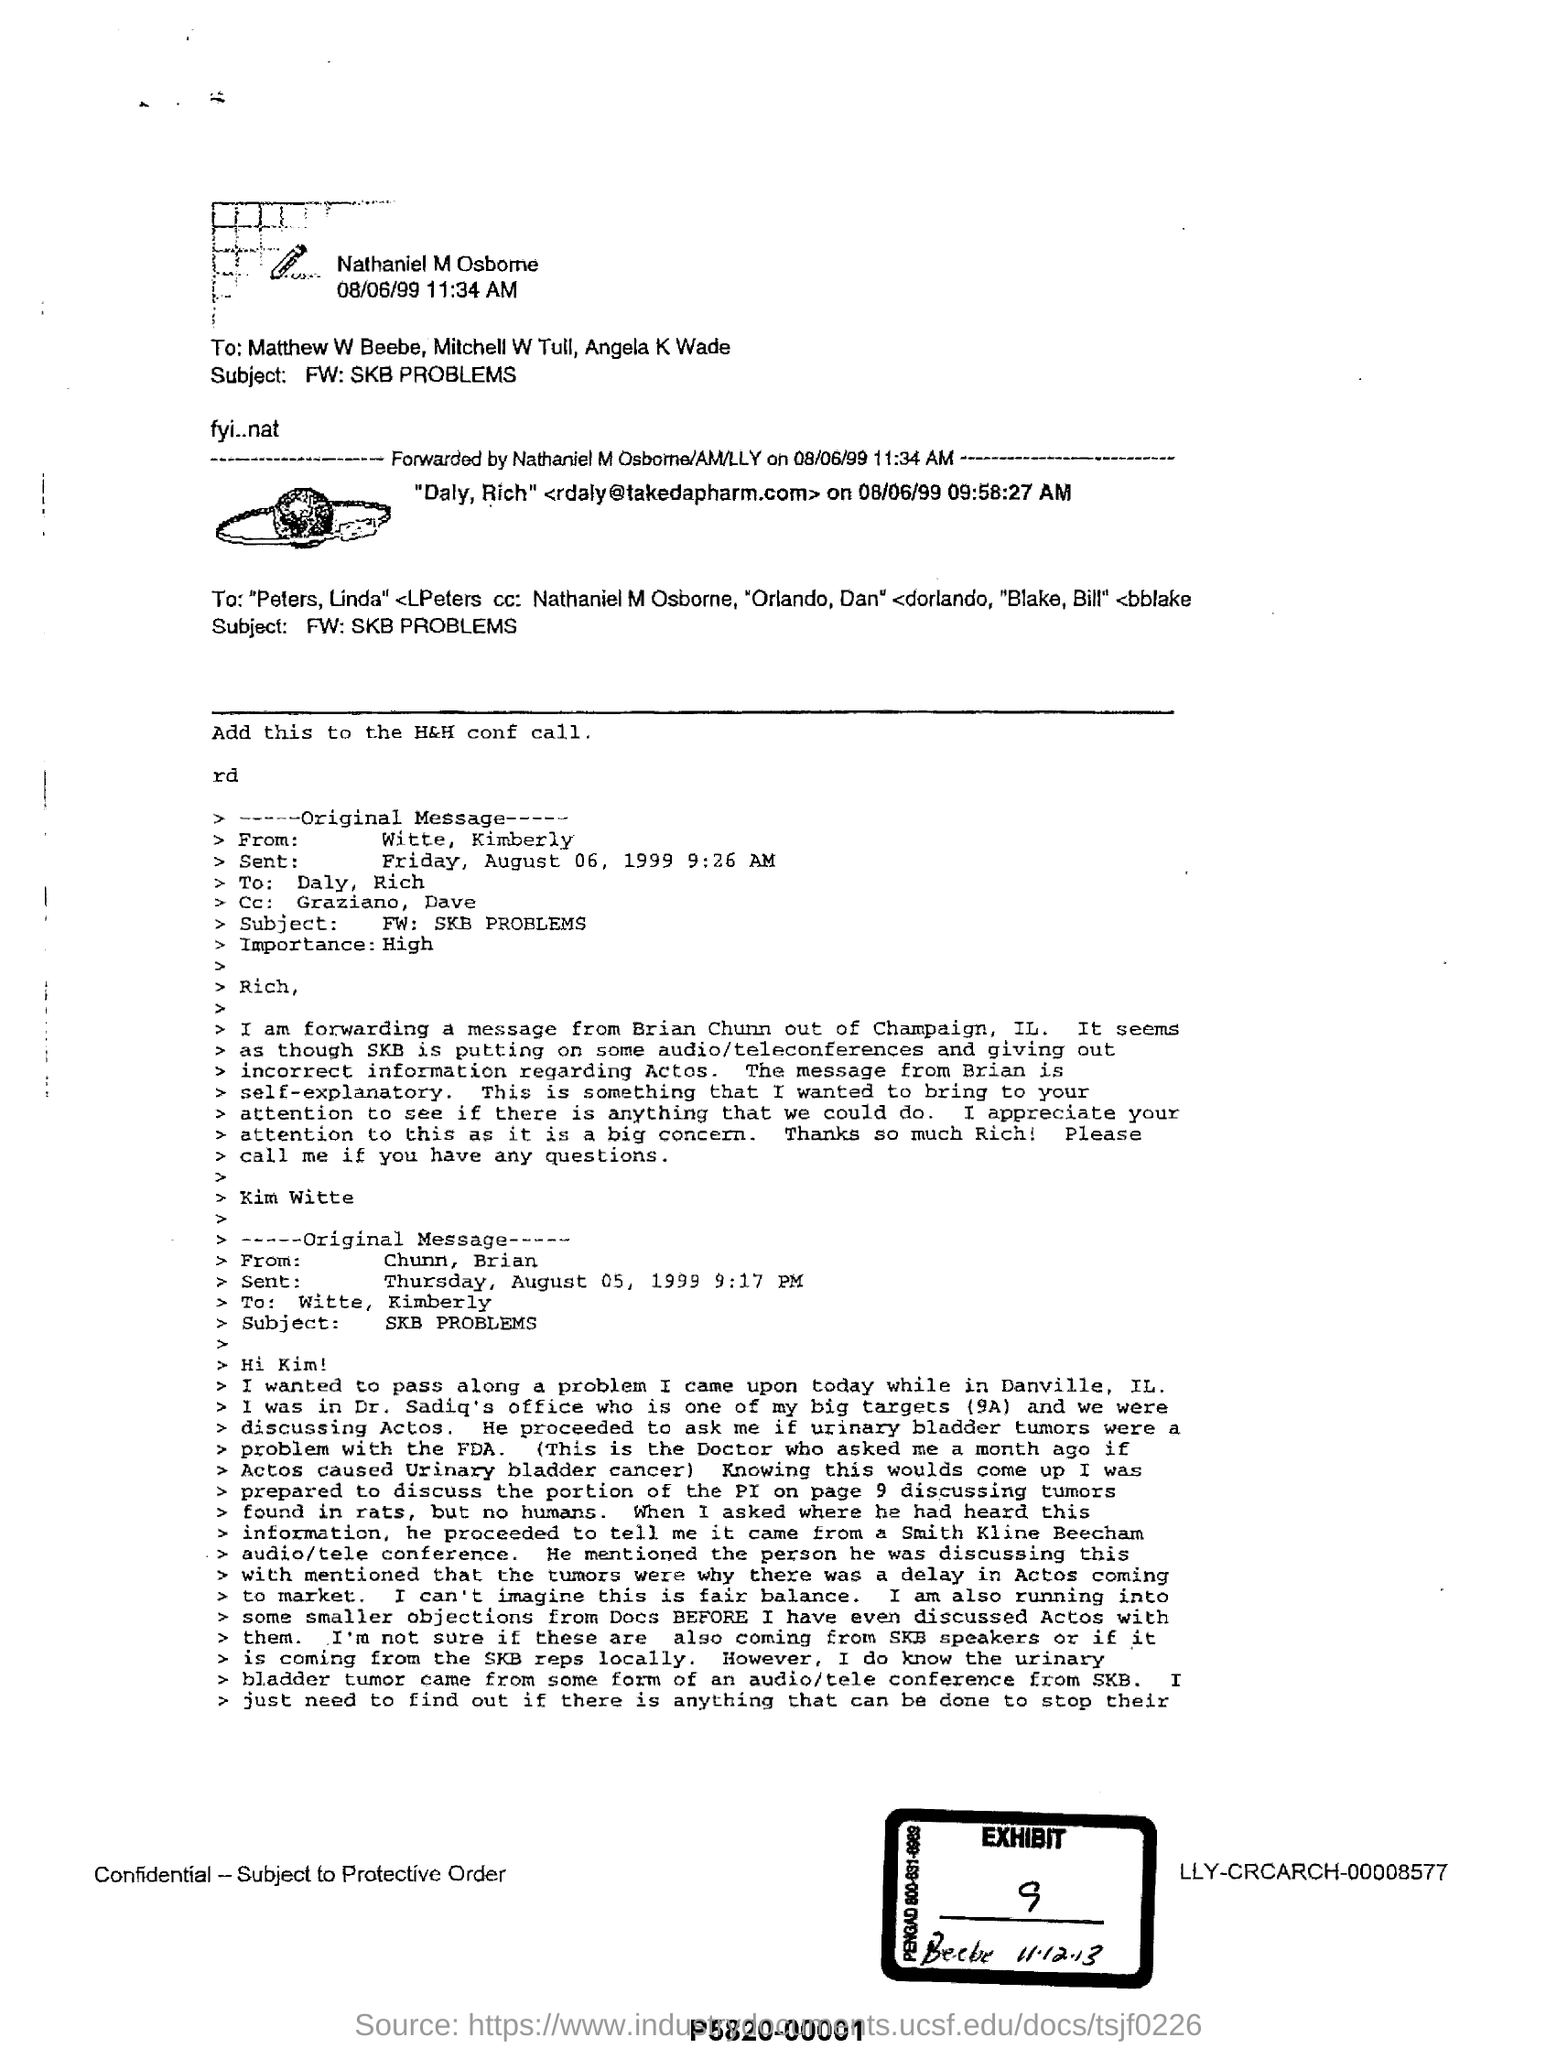List a handful of essential elements in this visual. The subject of the document is the problems with skb. The exhibit number given in the document is 9. The email sent by Witte, Kimberly is considered to be of high importance. The EXHIBIT number mentioned is 9. 